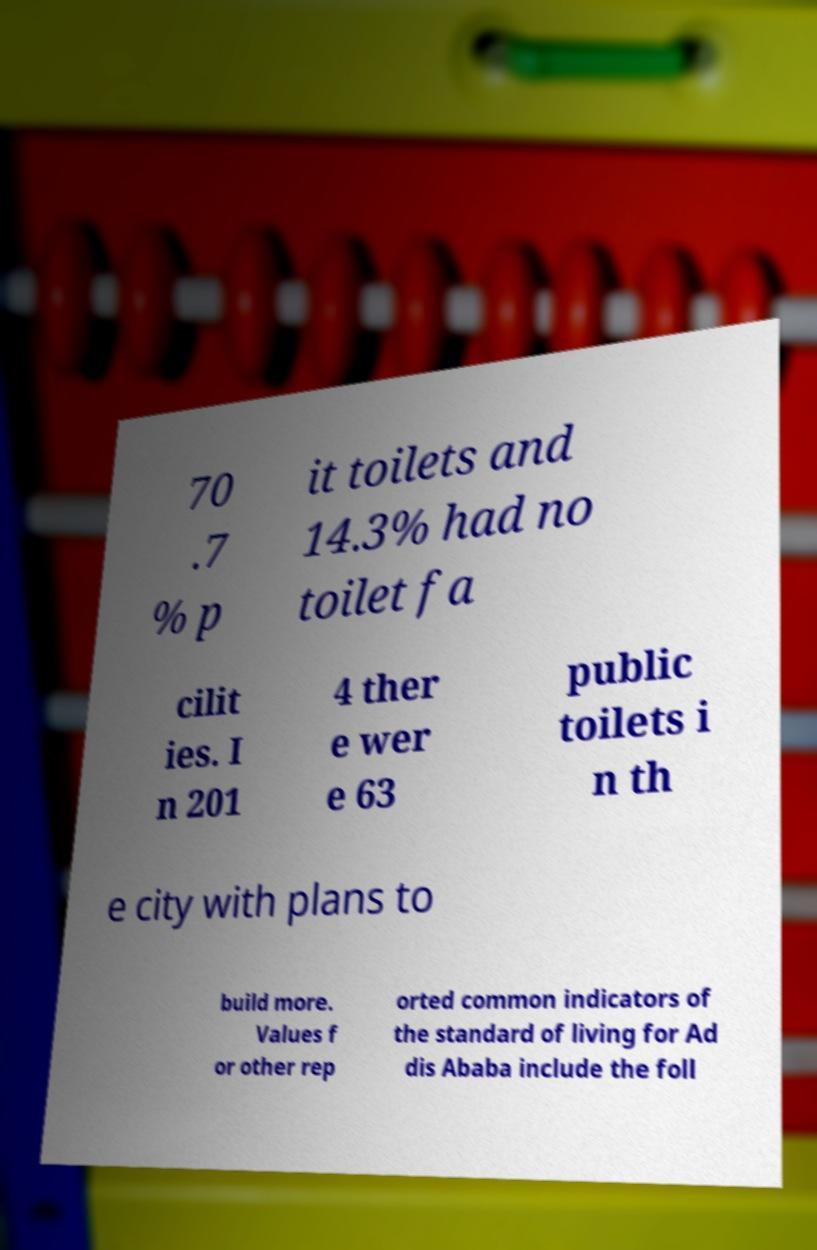What messages or text are displayed in this image? I need them in a readable, typed format. 70 .7 % p it toilets and 14.3% had no toilet fa cilit ies. I n 201 4 ther e wer e 63 public toilets i n th e city with plans to build more. Values f or other rep orted common indicators of the standard of living for Ad dis Ababa include the foll 